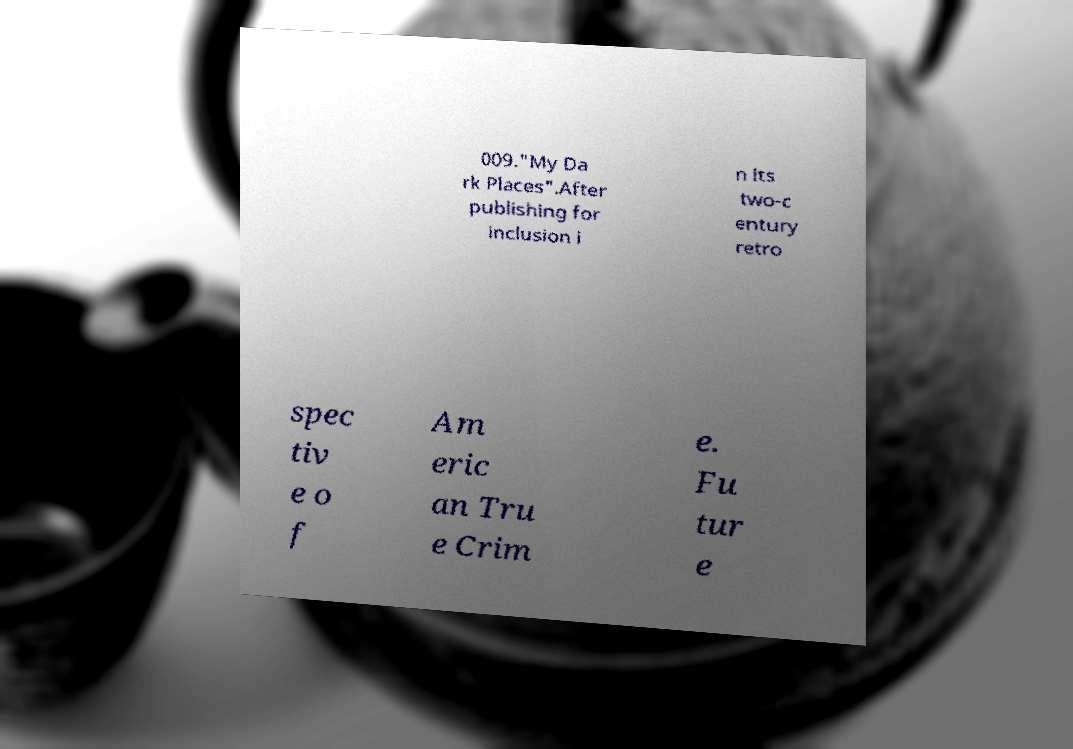I need the written content from this picture converted into text. Can you do that? 009."My Da rk Places".After publishing for inclusion i n its two-c entury retro spec tiv e o f Am eric an Tru e Crim e. Fu tur e 